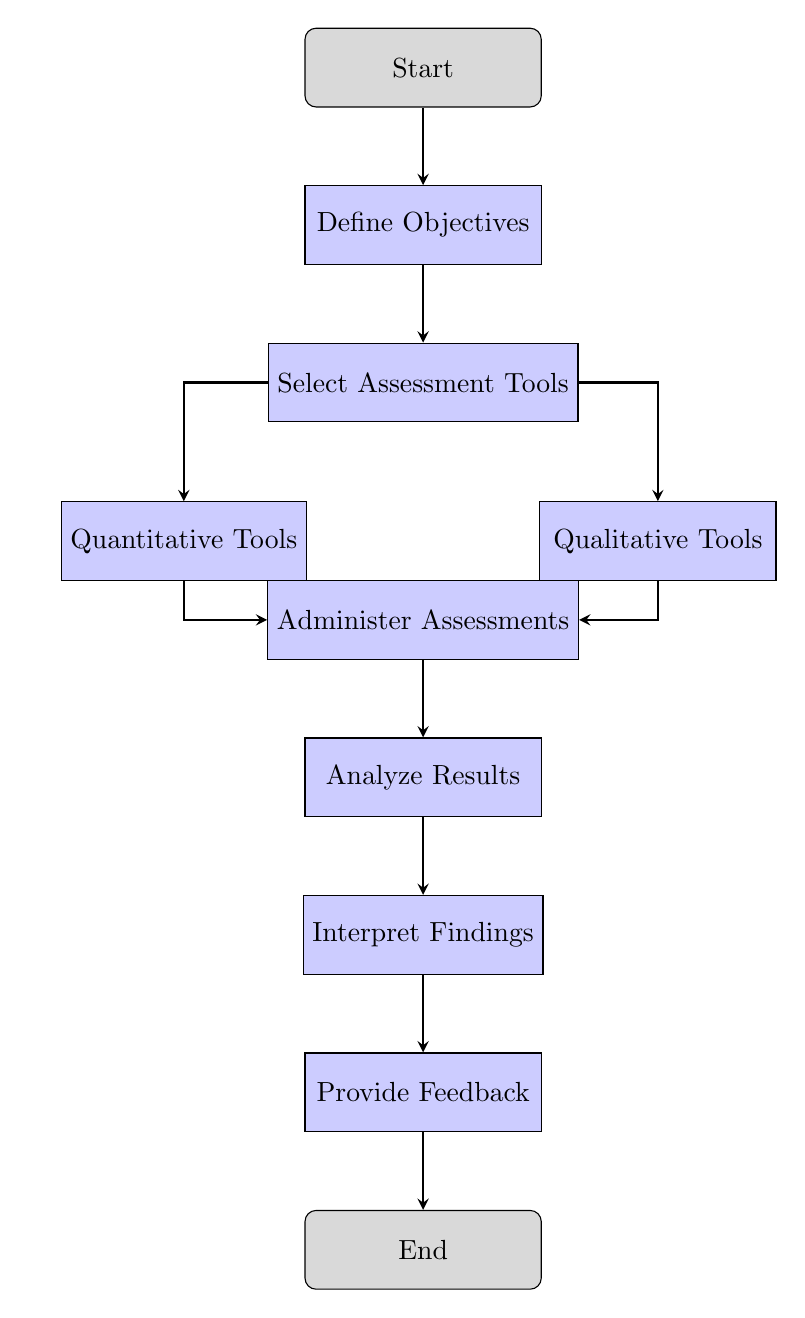What is the first step in the diagram? The first step according to the flowchart is the "Start" node. This indicates where the process begins.
Answer: Start How many assessment tools are selected? The "Select Assessment Tools" node splits into two branches: "Quantitative Tools" and "Qualitative Tools," indicating the selection of two types of assessment tools.
Answer: Two What follows after "Administer Assessments"? The flowchart shows that after "Administer Assessments," the next step is "Analyze Results." This is directly indicated by the arrow leading from "Administer Assessments" to "Analyze Results."
Answer: Analyze Results In which node do the results get analyzed? The "Analyze Results" node is where the results are evaluated, as indicated by the flow proceeding from "Administer Assessments" to "Analyze Results."
Answer: Analyze Results How many total nodes are present in the diagram? Counting all nodes from "Start" to "End," there are ten nodes in total, including all the tasks and events.
Answer: Ten What are the two types of tools involved in the assessment process? The diagram explicitly names two types of assessment tools: "Quantitative Tools" and "Qualitative Tools," which are shown as branches from the "Select Assessment Tools" step.
Answer: Quantitative Tools and Qualitative Tools What is the final action taken before the process ends? The last action before reaching "End" is "Provide Feedback." This is shown directly before the final "End" node in the flowchart.
Answer: Provide Feedback Which step comes after interpreting the findings? According to the flowchart, after interpreting the findings, the next step is to "Provide Feedback," which proceeds directly from the "Interpret Findings" node.
Answer: Provide Feedback 